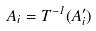Convert formula to latex. <formula><loc_0><loc_0><loc_500><loc_500>A _ { i } = T ^ { - 1 } ( A _ { i } ^ { \prime } )</formula> 